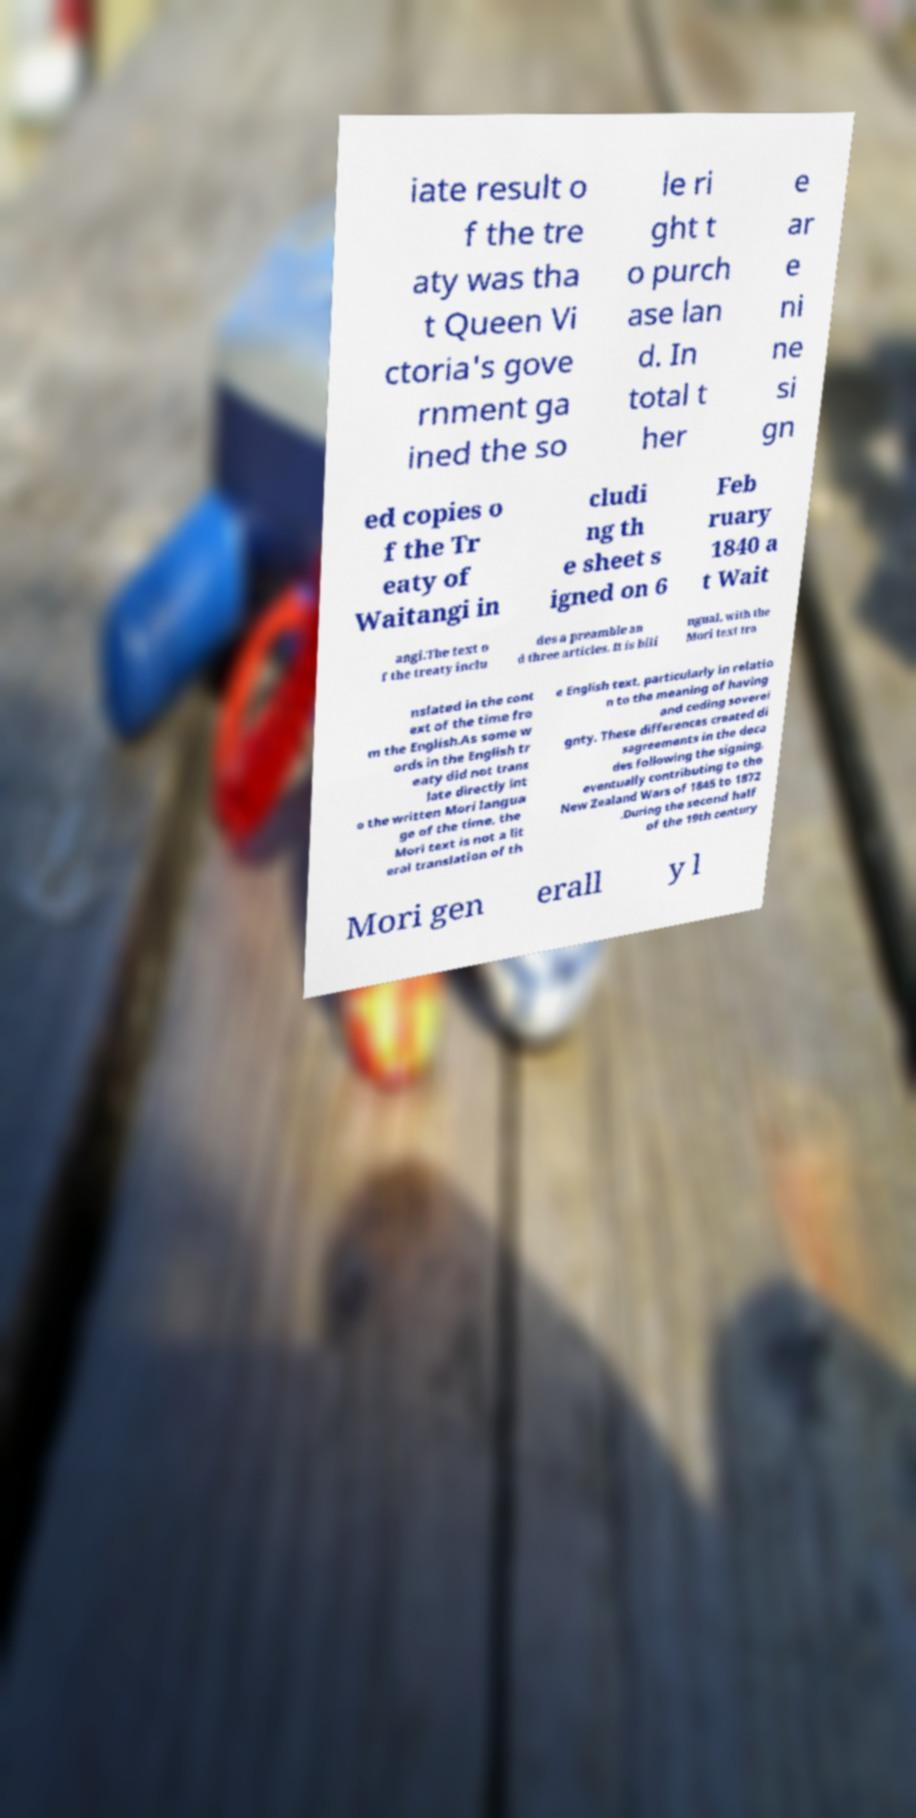I need the written content from this picture converted into text. Can you do that? iate result o f the tre aty was tha t Queen Vi ctoria's gove rnment ga ined the so le ri ght t o purch ase lan d. In total t her e ar e ni ne si gn ed copies o f the Tr eaty of Waitangi in cludi ng th e sheet s igned on 6 Feb ruary 1840 a t Wait angi.The text o f the treaty inclu des a preamble an d three articles. It is bili ngual, with the Mori text tra nslated in the cont ext of the time fro m the English.As some w ords in the English tr eaty did not trans late directly int o the written Mori langua ge of the time, the Mori text is not a lit eral translation of th e English text, particularly in relatio n to the meaning of having and ceding soverei gnty. These differences created di sagreements in the deca des following the signing, eventually contributing to the New Zealand Wars of 1845 to 1872 .During the second half of the 19th century Mori gen erall y l 